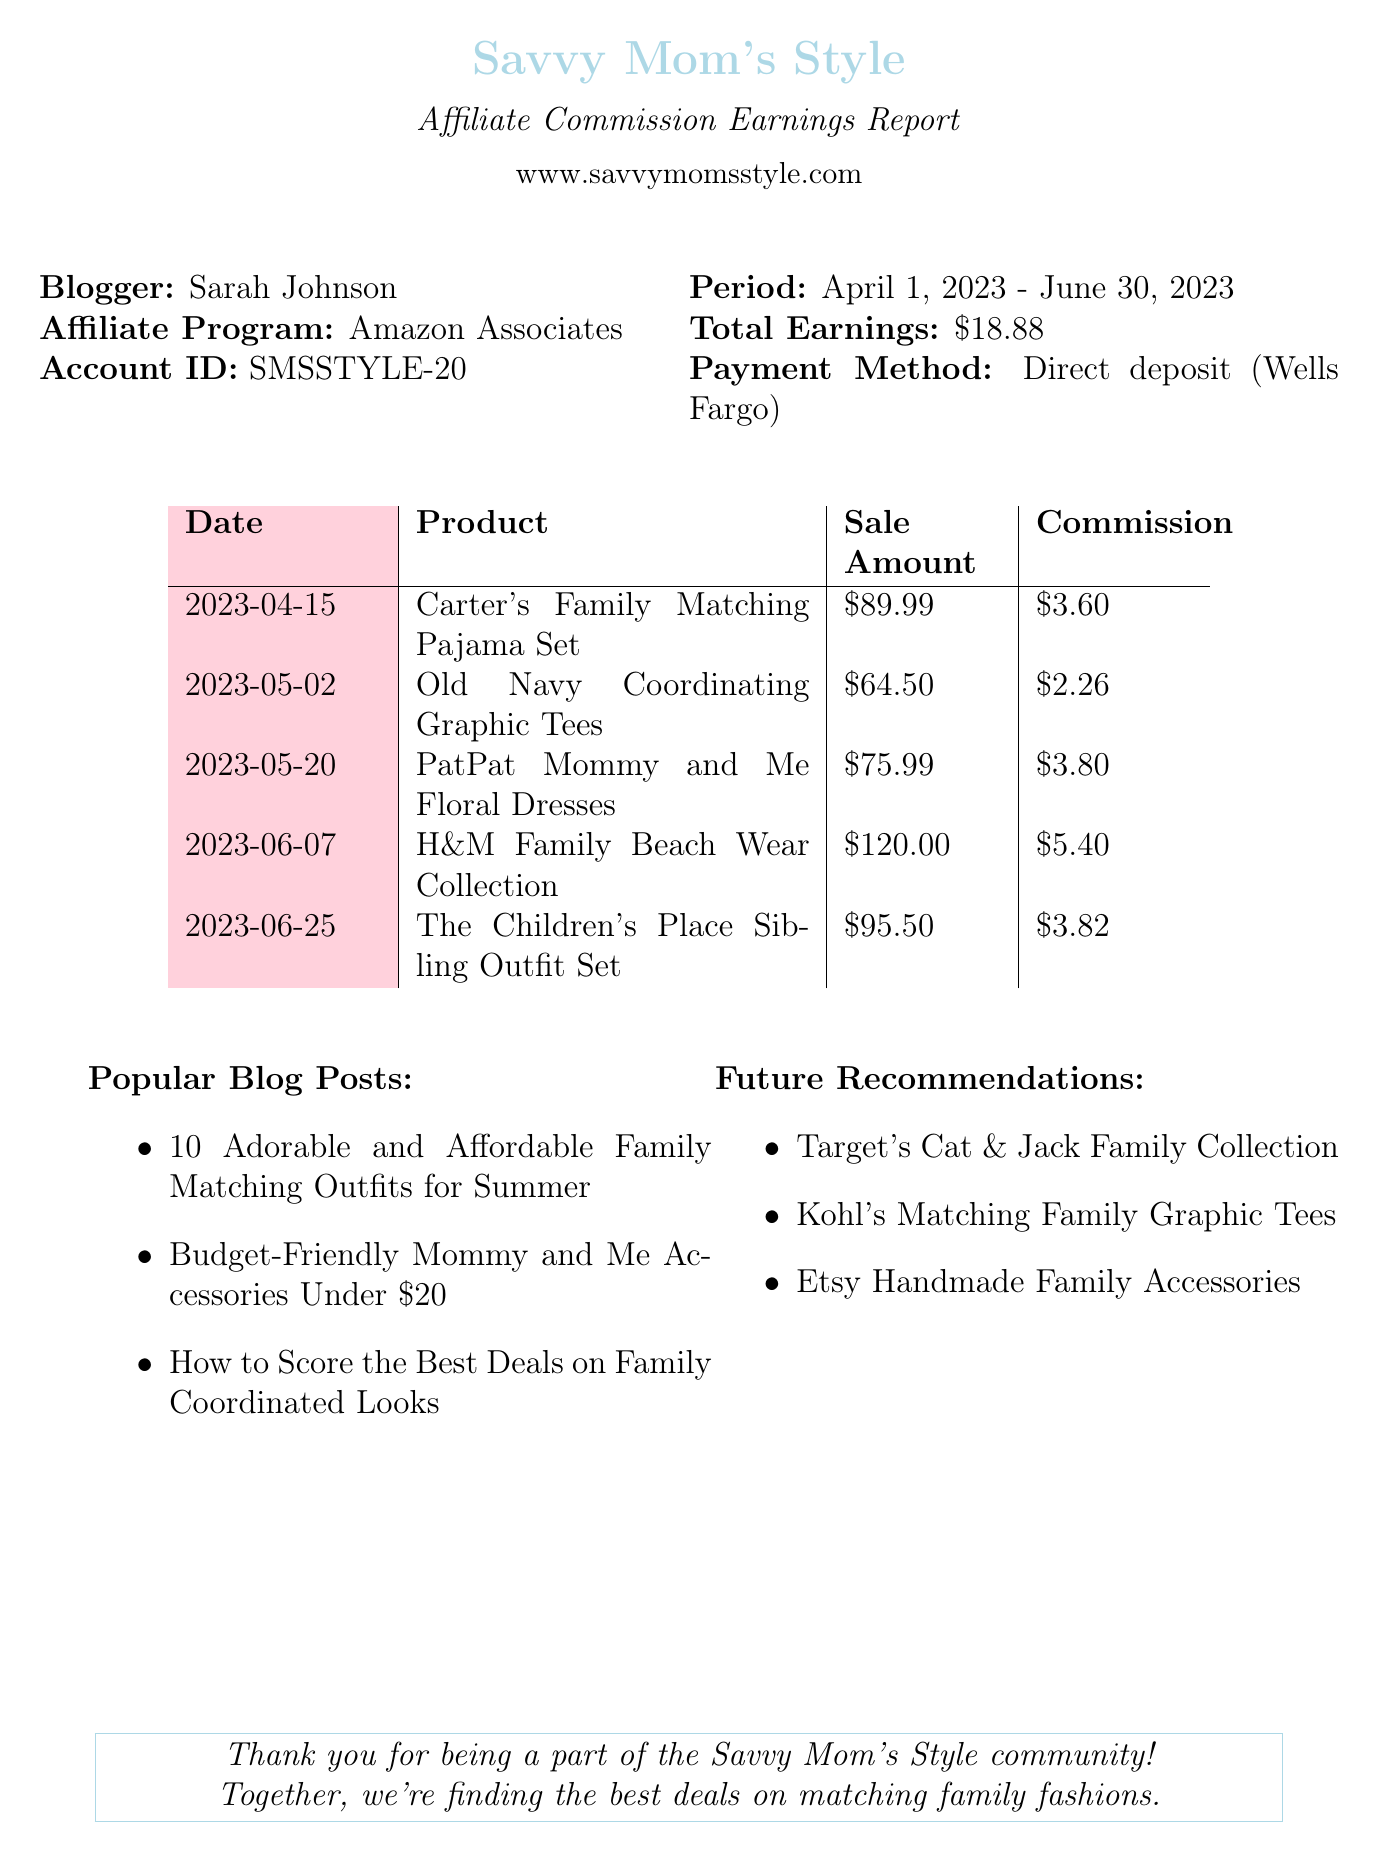What is the name of the blogger? The document states the blogger's name is Sarah Johnson.
Answer: Sarah Johnson What product earned the highest commission? By comparing the commission earned from each product, the highest was from the H&M Family Beach Wear Collection with a commission of $5.40.
Answer: H&M Family Beach Wear Collection What is the total earnings from the affiliate program? The total earnings are explicitly mentioned in the document as $18.88.
Answer: $18.88 What is the payment method used? The document specifies that the payment method is Direct deposit.
Answer: Direct deposit On what date was the Carter's Family Matching Pajama Set sold? The document lists the sale date of this product as April 15, 2023.
Answer: April 15, 2023 How much commission was earned from the Old Navy Coordinating Graphic Tees? The commission earned from the Old Navy product is provided in the document as $2.26.
Answer: $2.26 Which affiliate program is the blogger part of? The document mentions that the affiliate program is Amazon Associates.
Answer: Amazon Associates What is one of the future recommendations for family matching products? The document lists Target's Cat & Jack Family Collection as one of the future recommendations.
Answer: Target's Cat & Jack Family Collection What is the website of Savvy Mom's Style? The document states the website as www.savvymomsstyle.com.
Answer: www.savvymomsstyle.com 